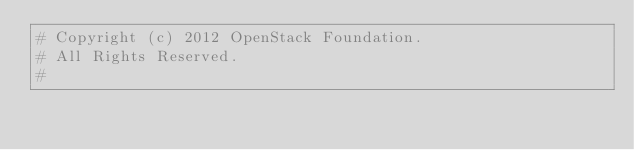Convert code to text. <code><loc_0><loc_0><loc_500><loc_500><_Python_># Copyright (c) 2012 OpenStack Foundation.
# All Rights Reserved.
#</code> 